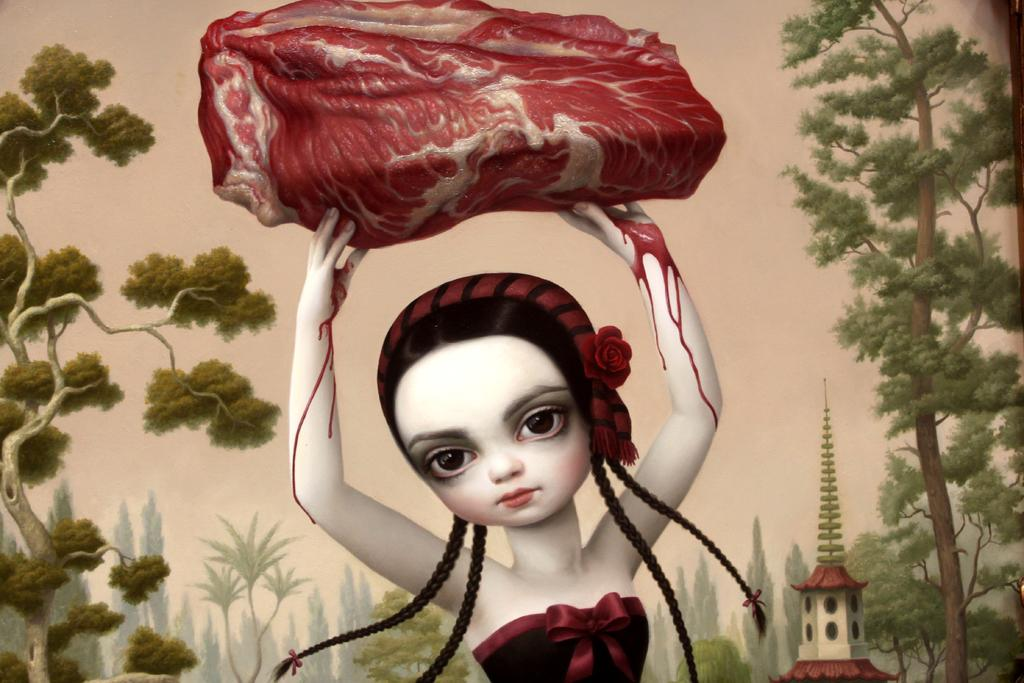What type of natural elements can be seen in the image? There are trees in the image. What is the person in the image carrying? The person in the image is carrying some meat. Where is the tower located in the image? The tower is in the bottom right of the image. What advice does the person's grandmother give them in the image? There is no mention of a grandmother or any advice in the image. How does the person make a decision about the meat in the image? There is no indication of the person making a decision about the meat in the image. 